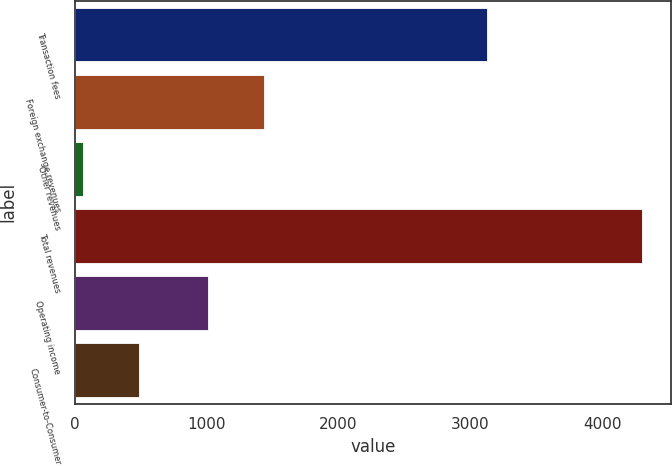<chart> <loc_0><loc_0><loc_500><loc_500><bar_chart><fcel>Transaction fees<fcel>Foreign exchange revenues<fcel>Other revenues<fcel>Total revenues<fcel>Operating income<fcel>Consumer-to-Consumer<nl><fcel>3123.8<fcel>1432.68<fcel>64.8<fcel>4304.6<fcel>1008.7<fcel>488.78<nl></chart> 